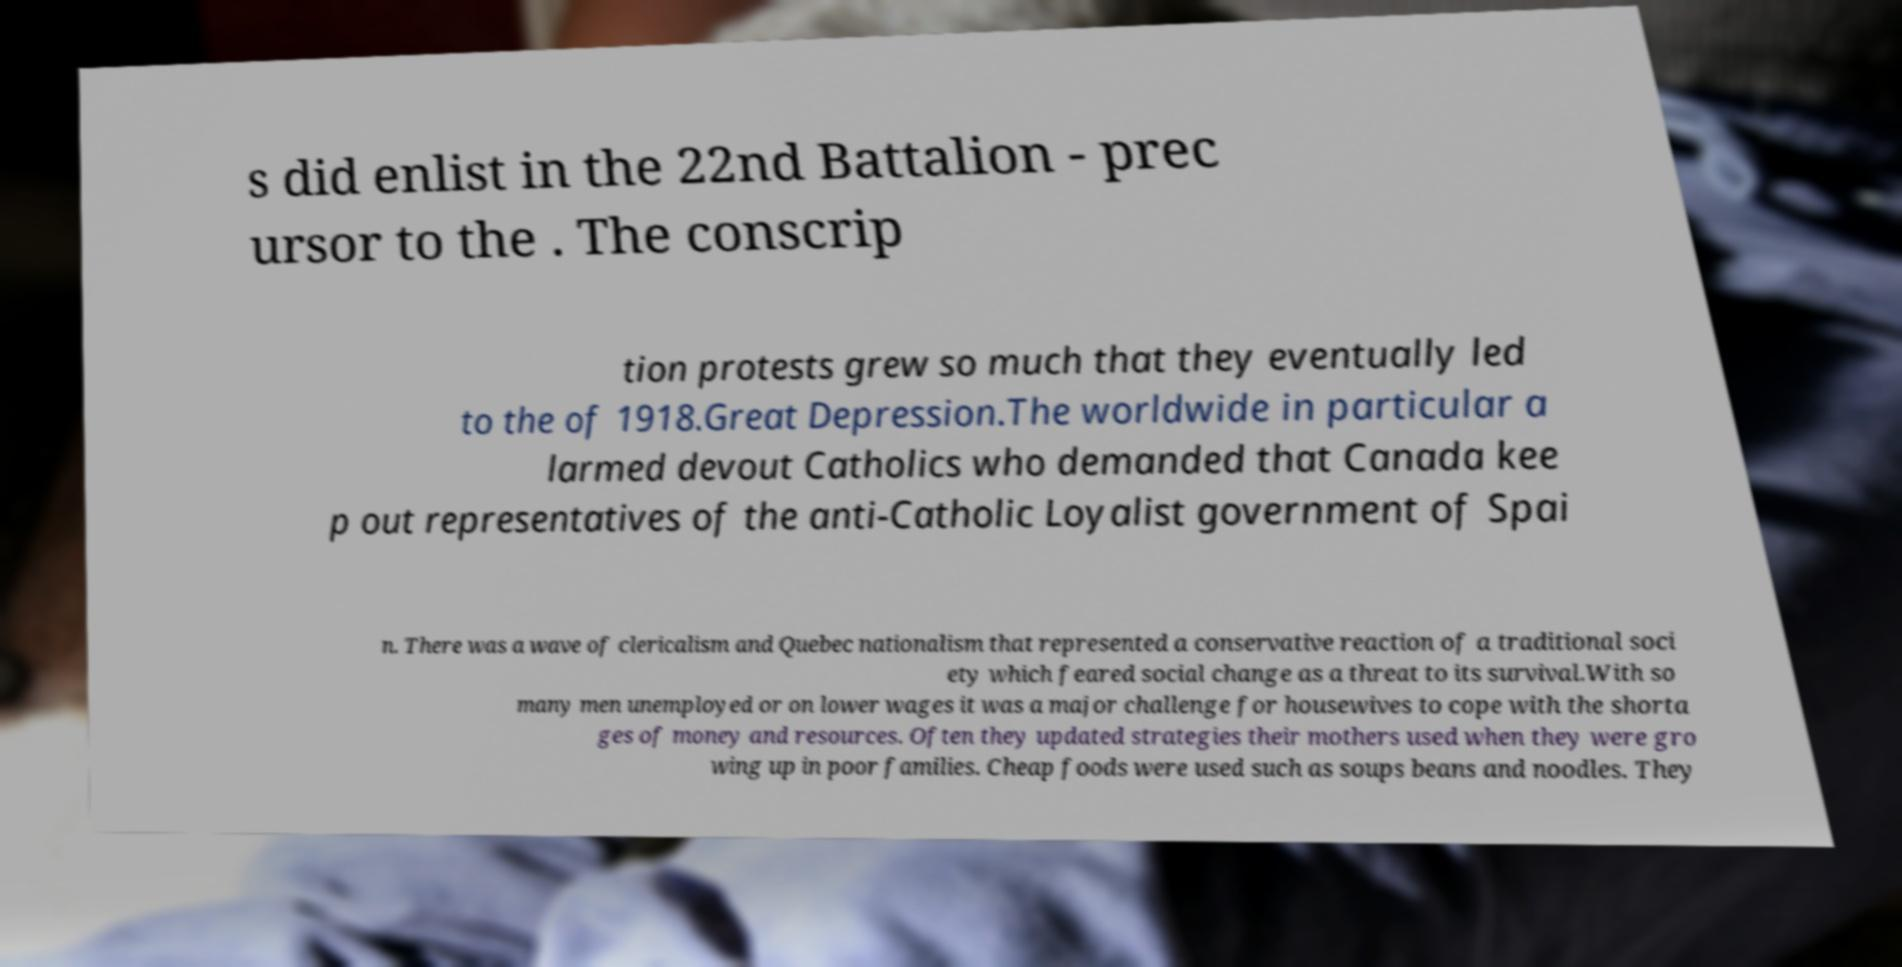Please identify and transcribe the text found in this image. s did enlist in the 22nd Battalion - prec ursor to the . The conscrip tion protests grew so much that they eventually led to the of 1918.Great Depression.The worldwide in particular a larmed devout Catholics who demanded that Canada kee p out representatives of the anti-Catholic Loyalist government of Spai n. There was a wave of clericalism and Quebec nationalism that represented a conservative reaction of a traditional soci ety which feared social change as a threat to its survival.With so many men unemployed or on lower wages it was a major challenge for housewives to cope with the shorta ges of money and resources. Often they updated strategies their mothers used when they were gro wing up in poor families. Cheap foods were used such as soups beans and noodles. They 